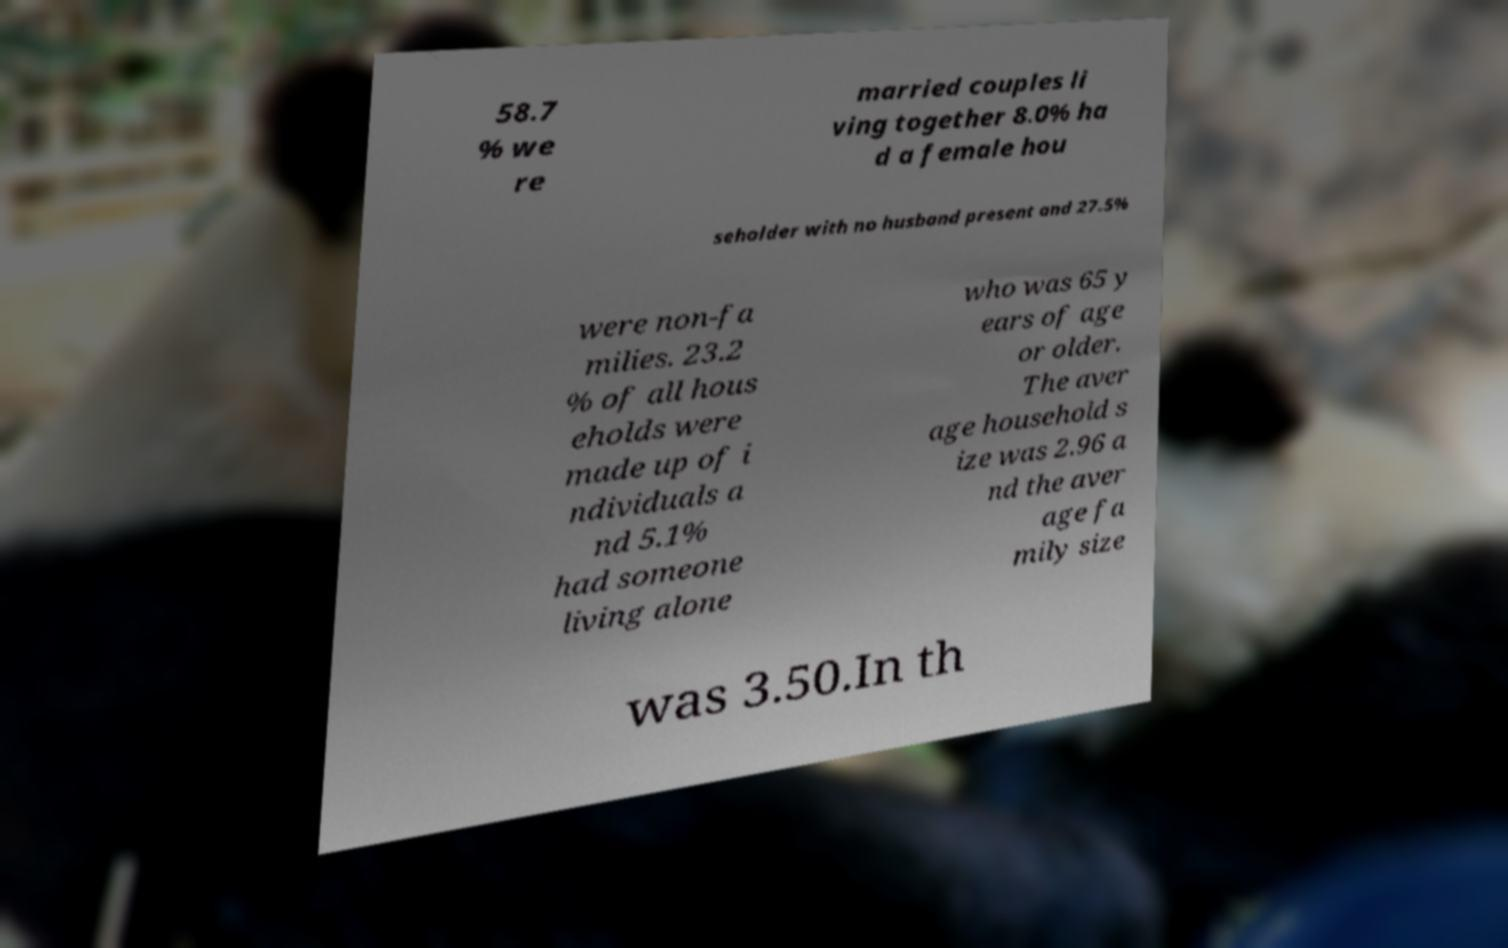Please identify and transcribe the text found in this image. 58.7 % we re married couples li ving together 8.0% ha d a female hou seholder with no husband present and 27.5% were non-fa milies. 23.2 % of all hous eholds were made up of i ndividuals a nd 5.1% had someone living alone who was 65 y ears of age or older. The aver age household s ize was 2.96 a nd the aver age fa mily size was 3.50.In th 